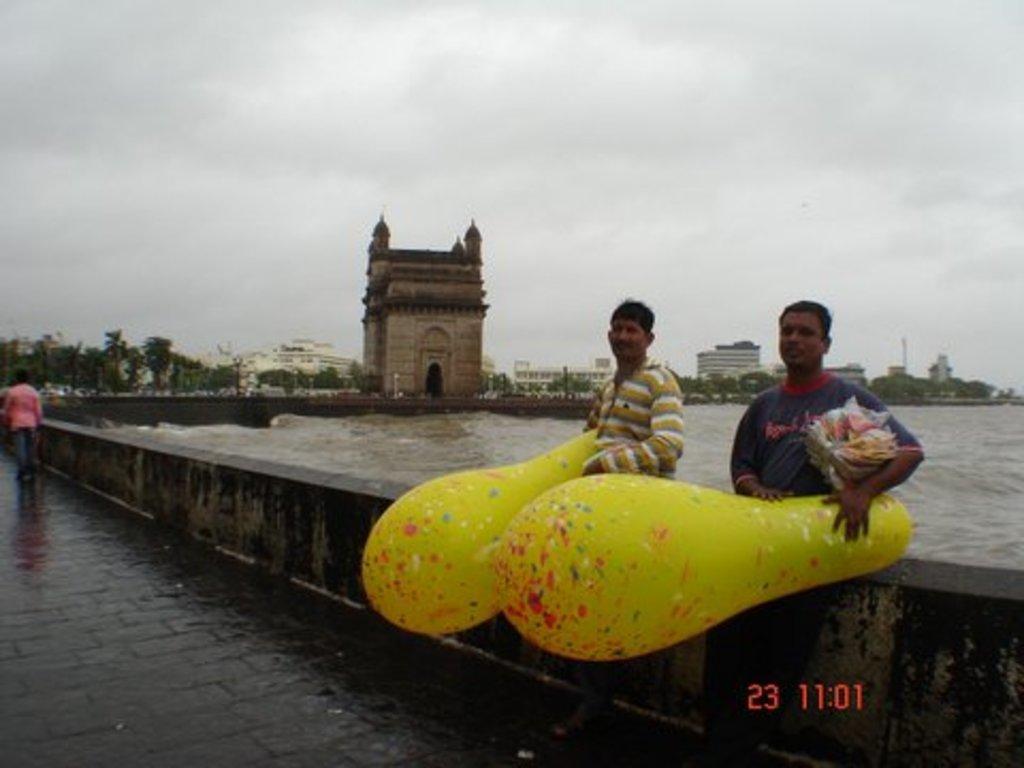In one or two sentences, can you explain what this image depicts? In this picture I can see the path in front, on which there are 2 men who are standing and holding balloons and other things in their hands and I can see the wall behind them. On the left side of this picture I can see a person. In the middle of this picture I can see the water, number of buildings and trees. In the background I can see the cloudy sky. 